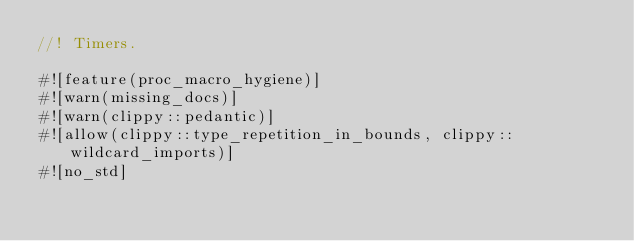<code> <loc_0><loc_0><loc_500><loc_500><_Rust_>//! Timers.

#![feature(proc_macro_hygiene)]
#![warn(missing_docs)]
#![warn(clippy::pedantic)]
#![allow(clippy::type_repetition_in_bounds, clippy::wildcard_imports)]
#![no_std]
</code> 